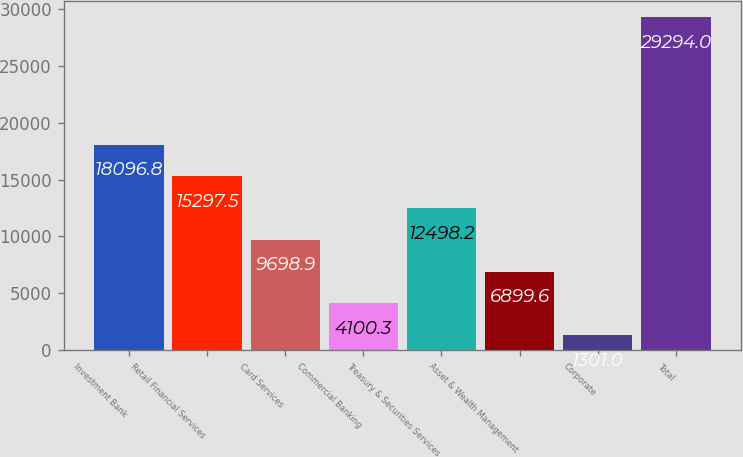<chart> <loc_0><loc_0><loc_500><loc_500><bar_chart><fcel>Investment Bank<fcel>Retail Financial Services<fcel>Card Services<fcel>Commercial Banking<fcel>Treasury & Securities Services<fcel>Asset & Wealth Management<fcel>Corporate<fcel>Total<nl><fcel>18096.8<fcel>15297.5<fcel>9698.9<fcel>4100.3<fcel>12498.2<fcel>6899.6<fcel>1301<fcel>29294<nl></chart> 